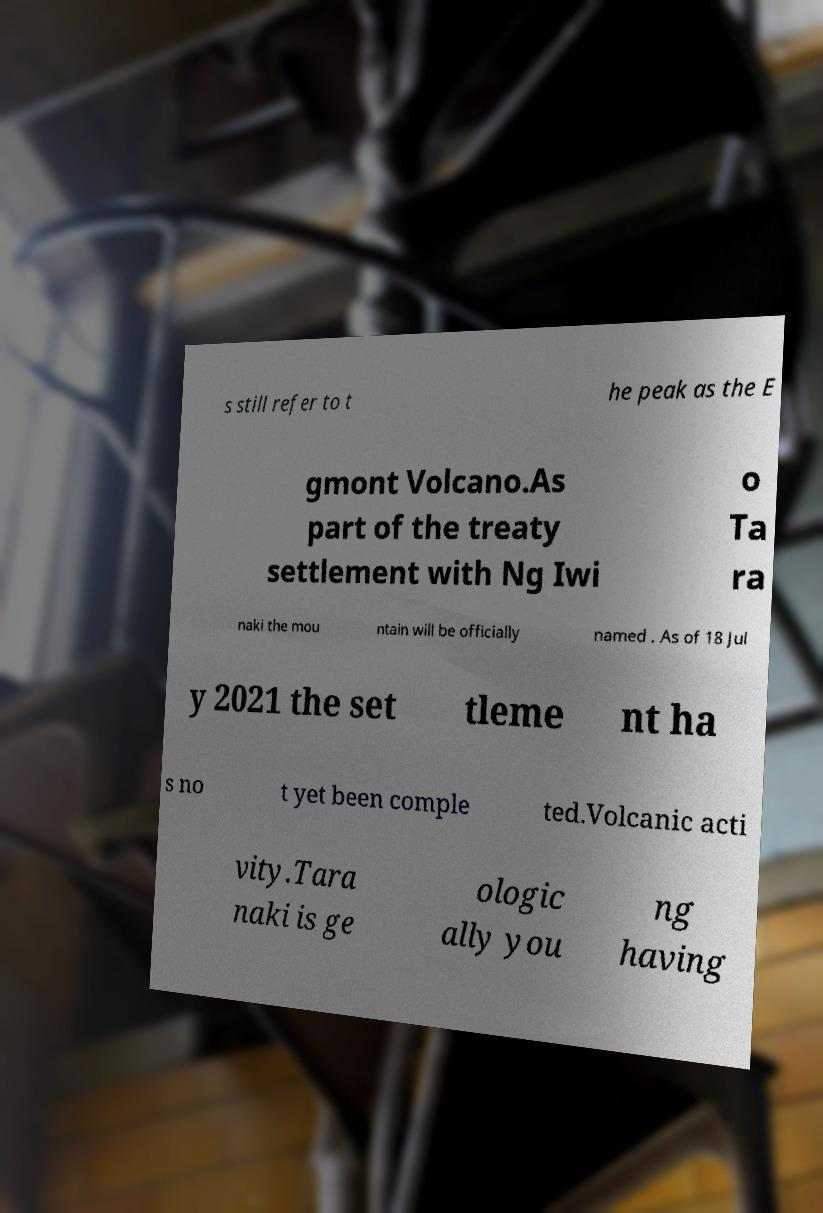Please identify and transcribe the text found in this image. s still refer to t he peak as the E gmont Volcano.As part of the treaty settlement with Ng Iwi o Ta ra naki the mou ntain will be officially named . As of 18 Jul y 2021 the set tleme nt ha s no t yet been comple ted.Volcanic acti vity.Tara naki is ge ologic ally you ng having 